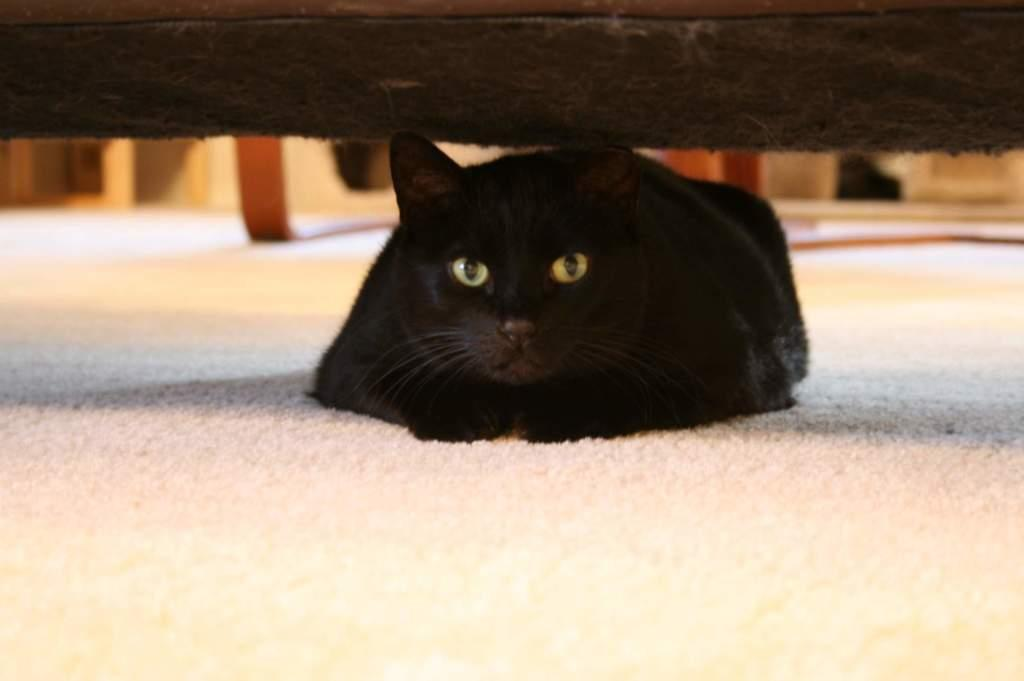What type of animal is in the image? There is a cat in the image. What can be seen at the top of the image? There is a black object at the top of the image. How would you describe the background of the image? The background of the image is blurred. What color is the surface at the bottom of the image? There is a white surface at the bottom of the image. Are there any cobwebs visible in the image? There is no mention of cobwebs in the provided facts, so we cannot determine if any are present in the image. 